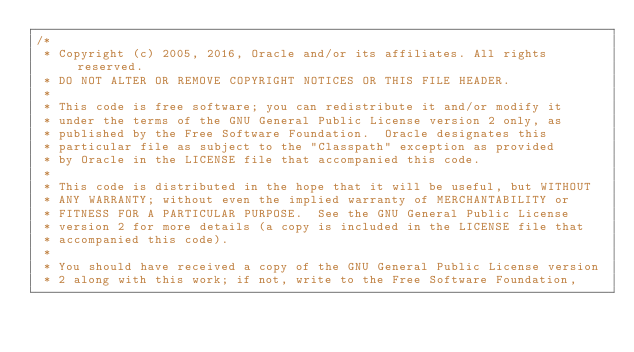Convert code to text. <code><loc_0><loc_0><loc_500><loc_500><_Java_>/*
 * Copyright (c) 2005, 2016, Oracle and/or its affiliates. All rights reserved.
 * DO NOT ALTER OR REMOVE COPYRIGHT NOTICES OR THIS FILE HEADER.
 *
 * This code is free software; you can redistribute it and/or modify it
 * under the terms of the GNU General Public License version 2 only, as
 * published by the Free Software Foundation.  Oracle designates this
 * particular file as subject to the "Classpath" exception as provided
 * by Oracle in the LICENSE file that accompanied this code.
 *
 * This code is distributed in the hope that it will be useful, but WITHOUT
 * ANY WARRANTY; without even the implied warranty of MERCHANTABILITY or
 * FITNESS FOR A PARTICULAR PURPOSE.  See the GNU General Public License
 * version 2 for more details (a copy is included in the LICENSE file that
 * accompanied this code).
 *
 * You should have received a copy of the GNU General Public License version
 * 2 along with this work; if not, write to the Free Software Foundation,</code> 